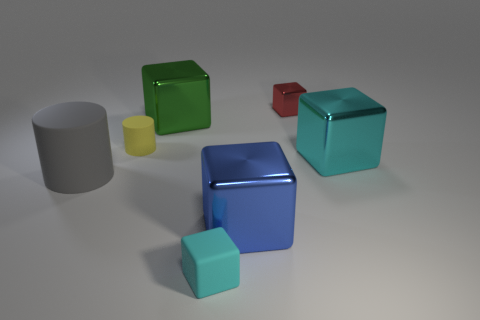Is there any other thing that has the same shape as the cyan metallic thing?
Offer a very short reply. Yes. What is the color of the cylinder that is behind the rubber cylinder that is in front of the tiny matte cylinder that is on the left side of the red object?
Ensure brevity in your answer.  Yellow. What number of big things are red objects or green rubber objects?
Make the answer very short. 0. Are there an equal number of yellow matte things in front of the large cyan thing and small cyan rubber objects?
Your response must be concise. No. There is a blue thing; are there any large blocks behind it?
Ensure brevity in your answer.  Yes. What number of metallic things are tiny blue cylinders or tiny cyan blocks?
Give a very brief answer. 0. What number of cyan shiny things are behind the cyan matte block?
Ensure brevity in your answer.  1. Is there a matte thing that has the same size as the green metal object?
Make the answer very short. Yes. Is there a metallic cube that has the same color as the rubber cube?
Give a very brief answer. Yes. What number of large metallic cubes are the same color as the small rubber cylinder?
Your response must be concise. 0. 